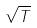<formula> <loc_0><loc_0><loc_500><loc_500>\sqrt { T }</formula> 